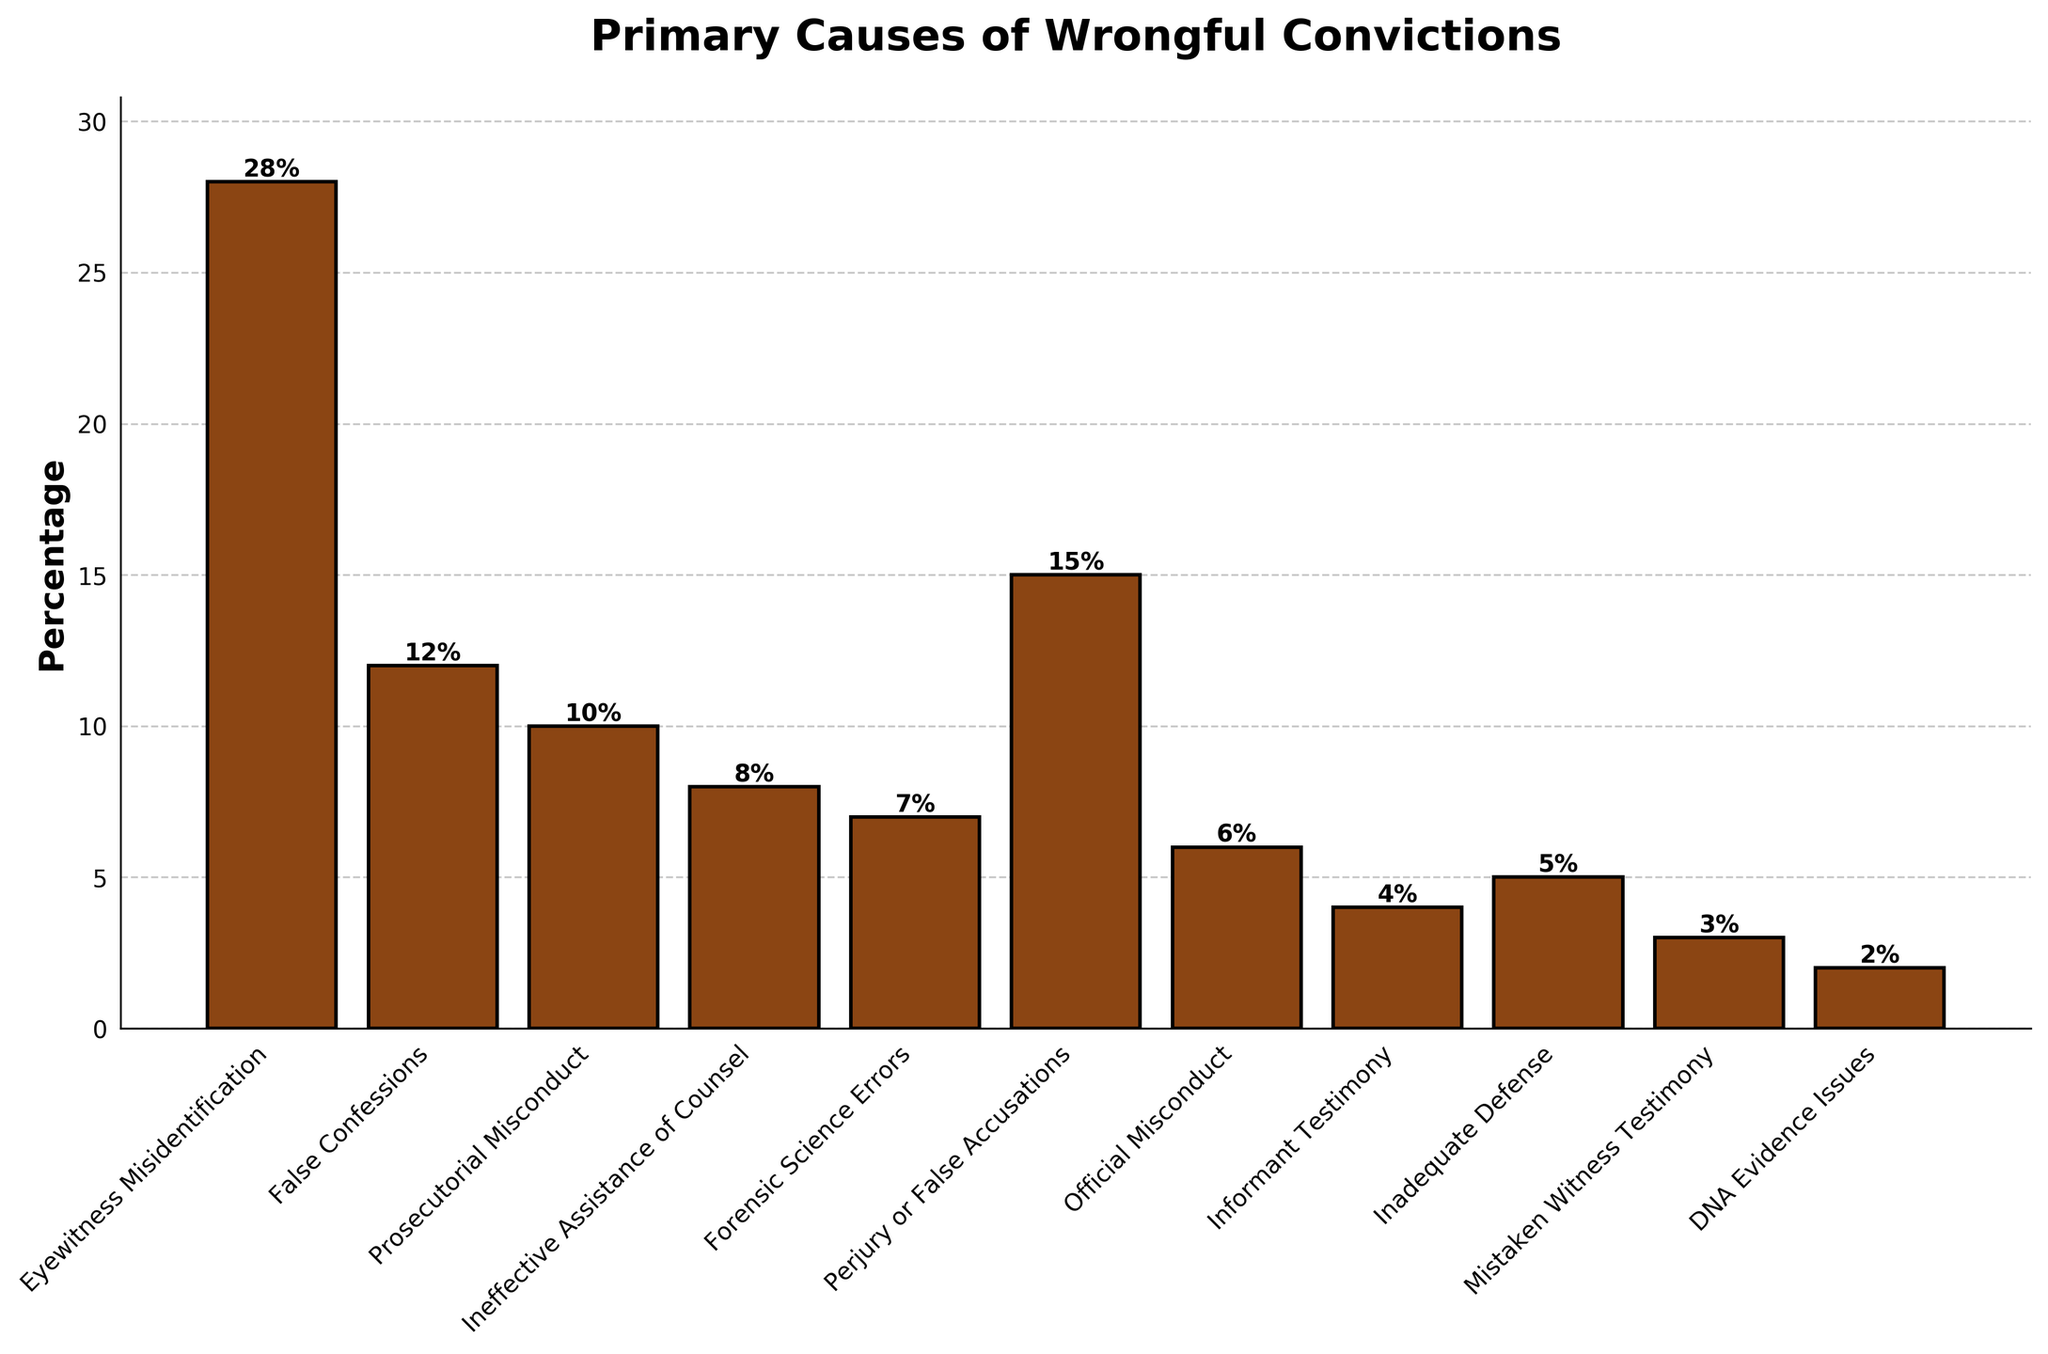What is the most frequent cause of wrongful convictions according to the chart? The chart visually displays the frequency of different causes of wrongful convictions. The bar representing "Eyewitness Misidentification" is the tallest. This indicates it has the highest percentage.
Answer: Eyewitness Misidentification Which causes have a higher percentage than False Confessions? The percentage for False Confessions is 12%. By comparing the bar heights, the bars for "Eyewitness Misidentification" and "Perjury or False Accusations" are taller, indicating higher percentages.
Answer: Eyewitness Misidentification and Perjury or False Accusations What is the combined percentage of Prosecutorial Misconduct and Ineffective Assistance of Counsel? The chart gives 10% for Prosecutorial Misconduct and 8% for Ineffective Assistance of Counsel. Adding these together gives a combined percentage of 10 + 8 = 18%.
Answer: 18% Which cause has the smallest bar? The smallest bar in the chart represents "DNA Evidence Issues".
Answer: DNA Evidence Issues How much higher is the percentage of Eyewitness Misidentification compared to False Confessions? The chart shows 28% for Eyewitness Misidentification and 12% for False Confessions. Subtract the smaller percentage from the larger one: 28 - 12 = 16%.
Answer: 16% What percentage of causes are related to testimonial errors (Eyewitness Misidentification, Perjury or False Accusations, and Mistaken Witness Testimony)? Determine the individual percentages: Eyewitness Misidentification (28%), Perjury or False Accusations (15%), and Mistaken Witness Testimony (3%). Sum these values: 28 + 15 + 3 = 46%.
Answer: 46% Which has a higher percentage, Informant Testimony or Official Misconduct? The chart shows 4% for Informant Testimony and 6% for Official Misconduct. Since 6% is greater than 4%, Official Misconduct has a higher percentage.
Answer: Official Misconduct What is the visual difference between the bars for Forensic Science Errors and Inadequate Defense? The chart shows the bar for Forensic Science Errors having a percentage of 7% and the bar for Inadequate Defense having a percentage of 5%. The bar for Forensic Science Errors is taller compared to the one for Inadequate Defense.
Answer: Forensic Science Errors is taller What is the percentage difference between Perjury or False Accusations and Ineffective Assistance of Counsel? The chart shows 15% for Perjury or False Accusations and 8% for Ineffective Assistance of Counsel. Subtract the smaller value from the larger one: 15 - 8 = 7%.
Answer: 7% What is the average percentage of all the causes listed? Sum all the percentages given by the chart: 28 + 12 + 10 + 8 + 7 + 15 + 6 + 4 + 5 + 3 + 2 = 100%. There are 11 causes. Divide the total sum by the number of causes: 100 / 11 ≈ 9.09%.
Answer: 9.09% 